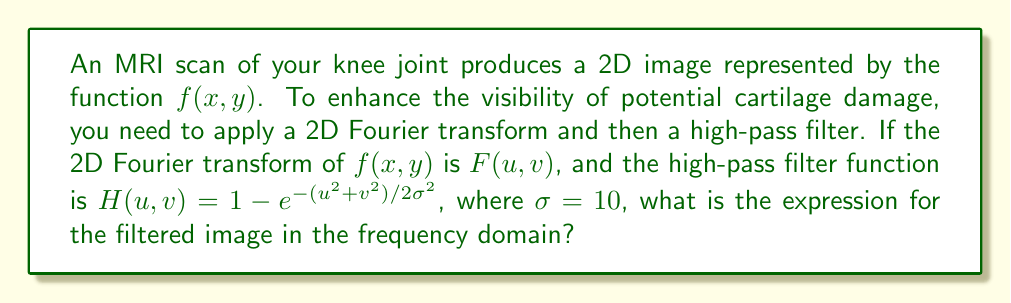Help me with this question. To solve this problem, we'll follow these steps:

1) The 2D Fourier transform of the image $f(x,y)$ is given as $F(u,v)$.

2) The high-pass filter function is provided as:

   $$H(u,v) = 1 - e^{-(u^2+v^2)/2\sigma^2}$$

   where $\sigma = 10$

3) To apply the filter in the frequency domain, we multiply the Fourier transform of the image by the filter function:

   $$G(u,v) = F(u,v) \cdot H(u,v)$$

4) Substituting the given filter function:

   $$G(u,v) = F(u,v) \cdot (1 - e^{-(u^2+v^2)/2\sigma^2})$$

5) Expanding this expression:

   $$G(u,v) = F(u,v) - F(u,v) \cdot e^{-(u^2+v^2)/200}$$

This expression represents the filtered image in the frequency domain, which enhances high-frequency components (potentially corresponding to cartilage damage) while attenuating low-frequency components.
Answer: $$G(u,v) = F(u,v) - F(u,v) \cdot e^{-(u^2+v^2)/200}$$ 